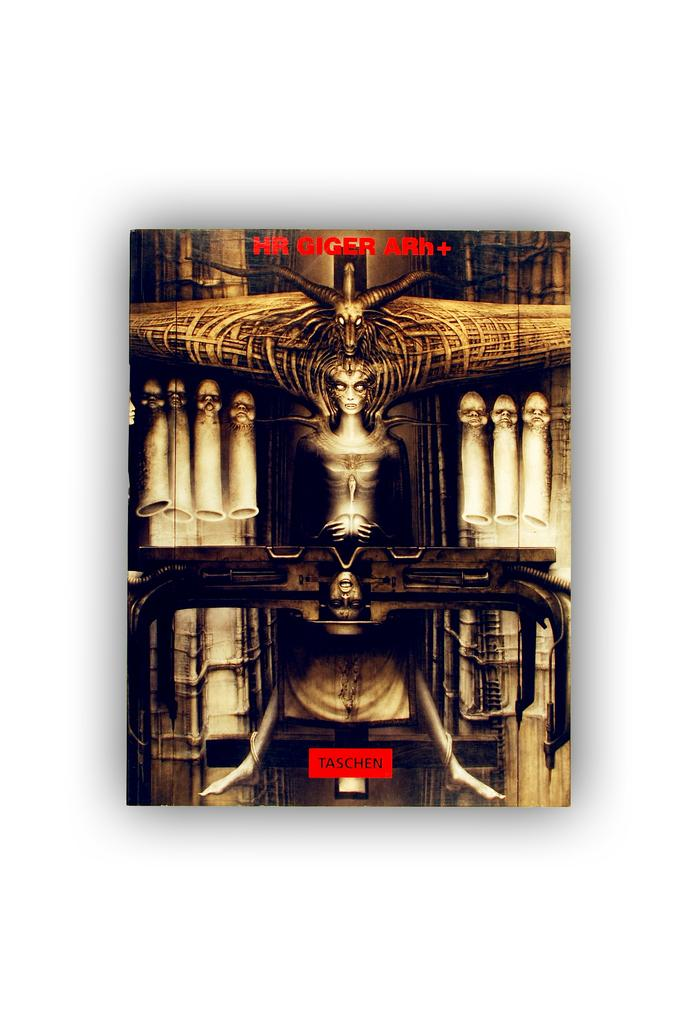<image>
Share a concise interpretation of the image provided. A poster that is made by HR Giger 